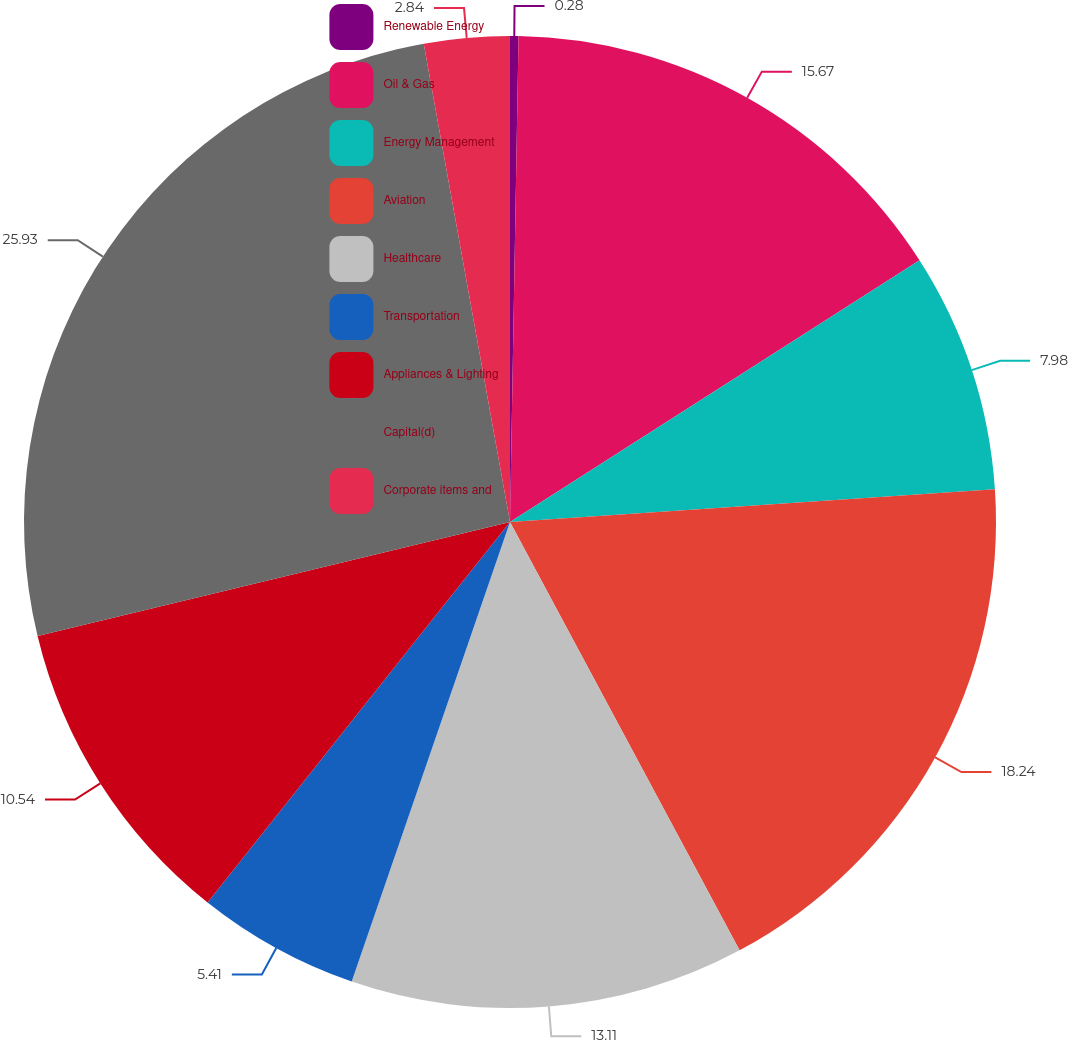Convert chart. <chart><loc_0><loc_0><loc_500><loc_500><pie_chart><fcel>Renewable Energy<fcel>Oil & Gas<fcel>Energy Management<fcel>Aviation<fcel>Healthcare<fcel>Transportation<fcel>Appliances & Lighting<fcel>Capital(d)<fcel>Corporate items and<nl><fcel>0.28%<fcel>15.67%<fcel>7.98%<fcel>18.24%<fcel>13.11%<fcel>5.41%<fcel>10.54%<fcel>25.93%<fcel>2.84%<nl></chart> 